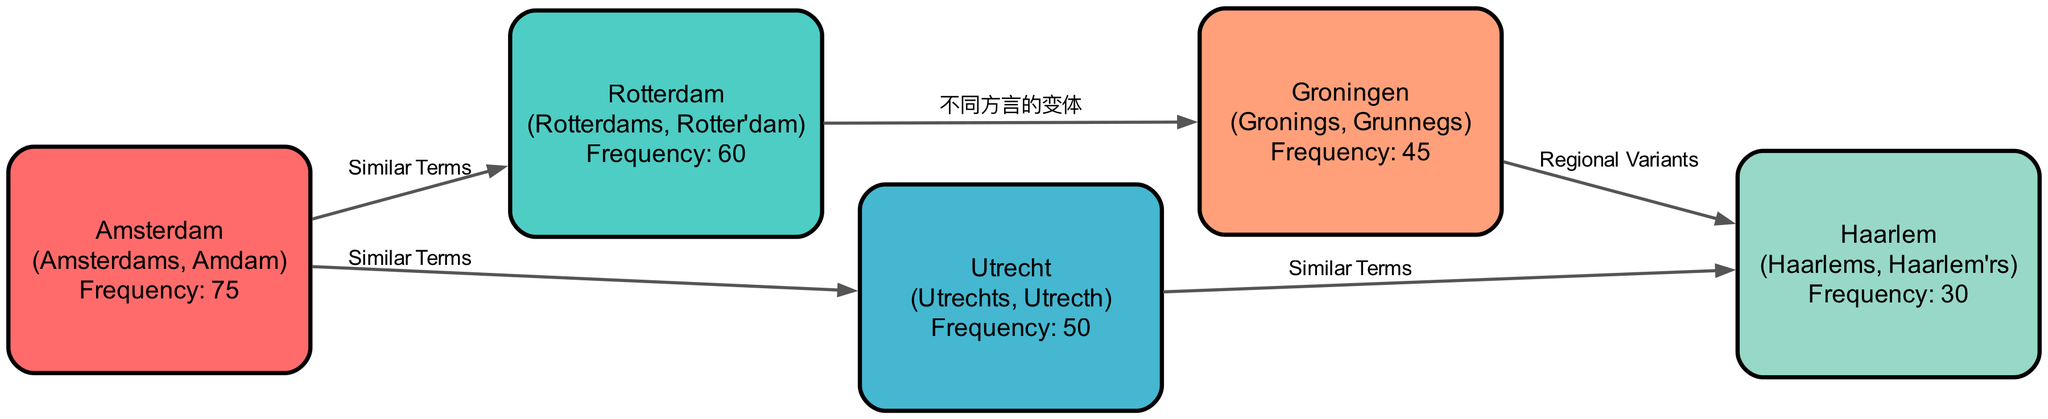What is the frequency of the term for Amsterdam? Observing the node labeled "Amsterdam," the frequency value displayed is 75. This is directly read from the graph.
Answer: 75 Which region shares a usage relation with Utrecht? Utrecht has an edge leading to Haarlem labeled "Similar Terms." This indicates a relationship, highlighting that these two regions have similar terminologies.
Answer: Haarlem How many nodes are present in the diagram? Counting the unique locations represented in the nodes section, there are five cities listed, thus there are five nodes in total.
Answer: 5 What are the variants for the term used in Groningen? The node for Groningen lists the variants as "Gronings" and "Grunnegs." This information is provided under the variants section specifically for Groningen.
Answer: Gronings, Grunnegs Which regions have a "Similar Terms" relationship? The edges between Amsterdam and Rotterdam, Amsterdam and Utrecht, and Utrecht and Haarlem are all labeled "Similar Terms," indicating they share similar linguistic characteristics.
Answer: Amsterdam, Rotterdam; Amsterdam, Utrecht; Utrecht, Haarlem What is the lowest frequency among the regions? Upon examining the frequency values, Haarlem has the lowest frequency at 30, which is less than any other region's frequency.
Answer: 30 Does Groningen have a relationship with Haarlem? If so, what type is it? The edge from Groningen to Haarlem is labeled "Regional Variants," indicating a specific type of relationship denoting regional terminological differences.
Answer: Regional Variants Which region has the highest frequency and what is the value? Amsterdam has the highest frequency at 75, which is higher than all other regions presented in the data.
Answer: 75 